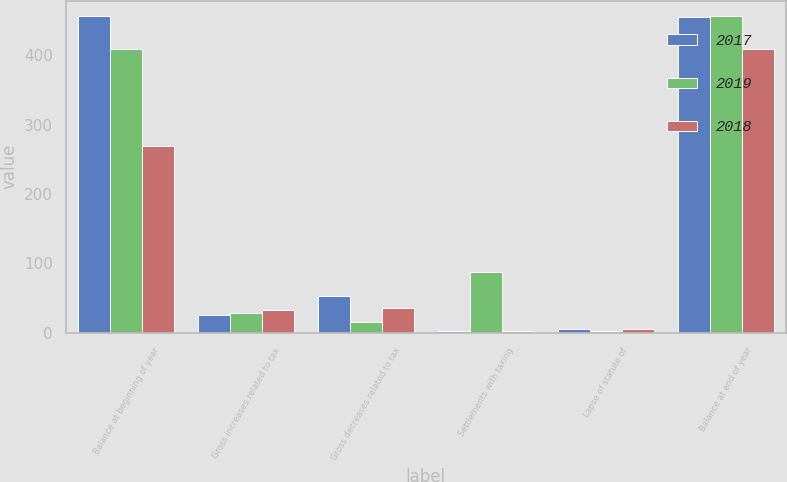<chart> <loc_0><loc_0><loc_500><loc_500><stacked_bar_chart><ecel><fcel>Balance at beginning of year<fcel>Gross increases related to tax<fcel>Gross decreases related to tax<fcel>Settlements with taxing<fcel>Lapse of statute of<fcel>Balance at end of year<nl><fcel>2017<fcel>456<fcel>26<fcel>53<fcel>2<fcel>5<fcel>455<nl><fcel>2019<fcel>409<fcel>29<fcel>15<fcel>87<fcel>3<fcel>456<nl><fcel>2018<fcel>269<fcel>33<fcel>36<fcel>2<fcel>5<fcel>409<nl></chart> 